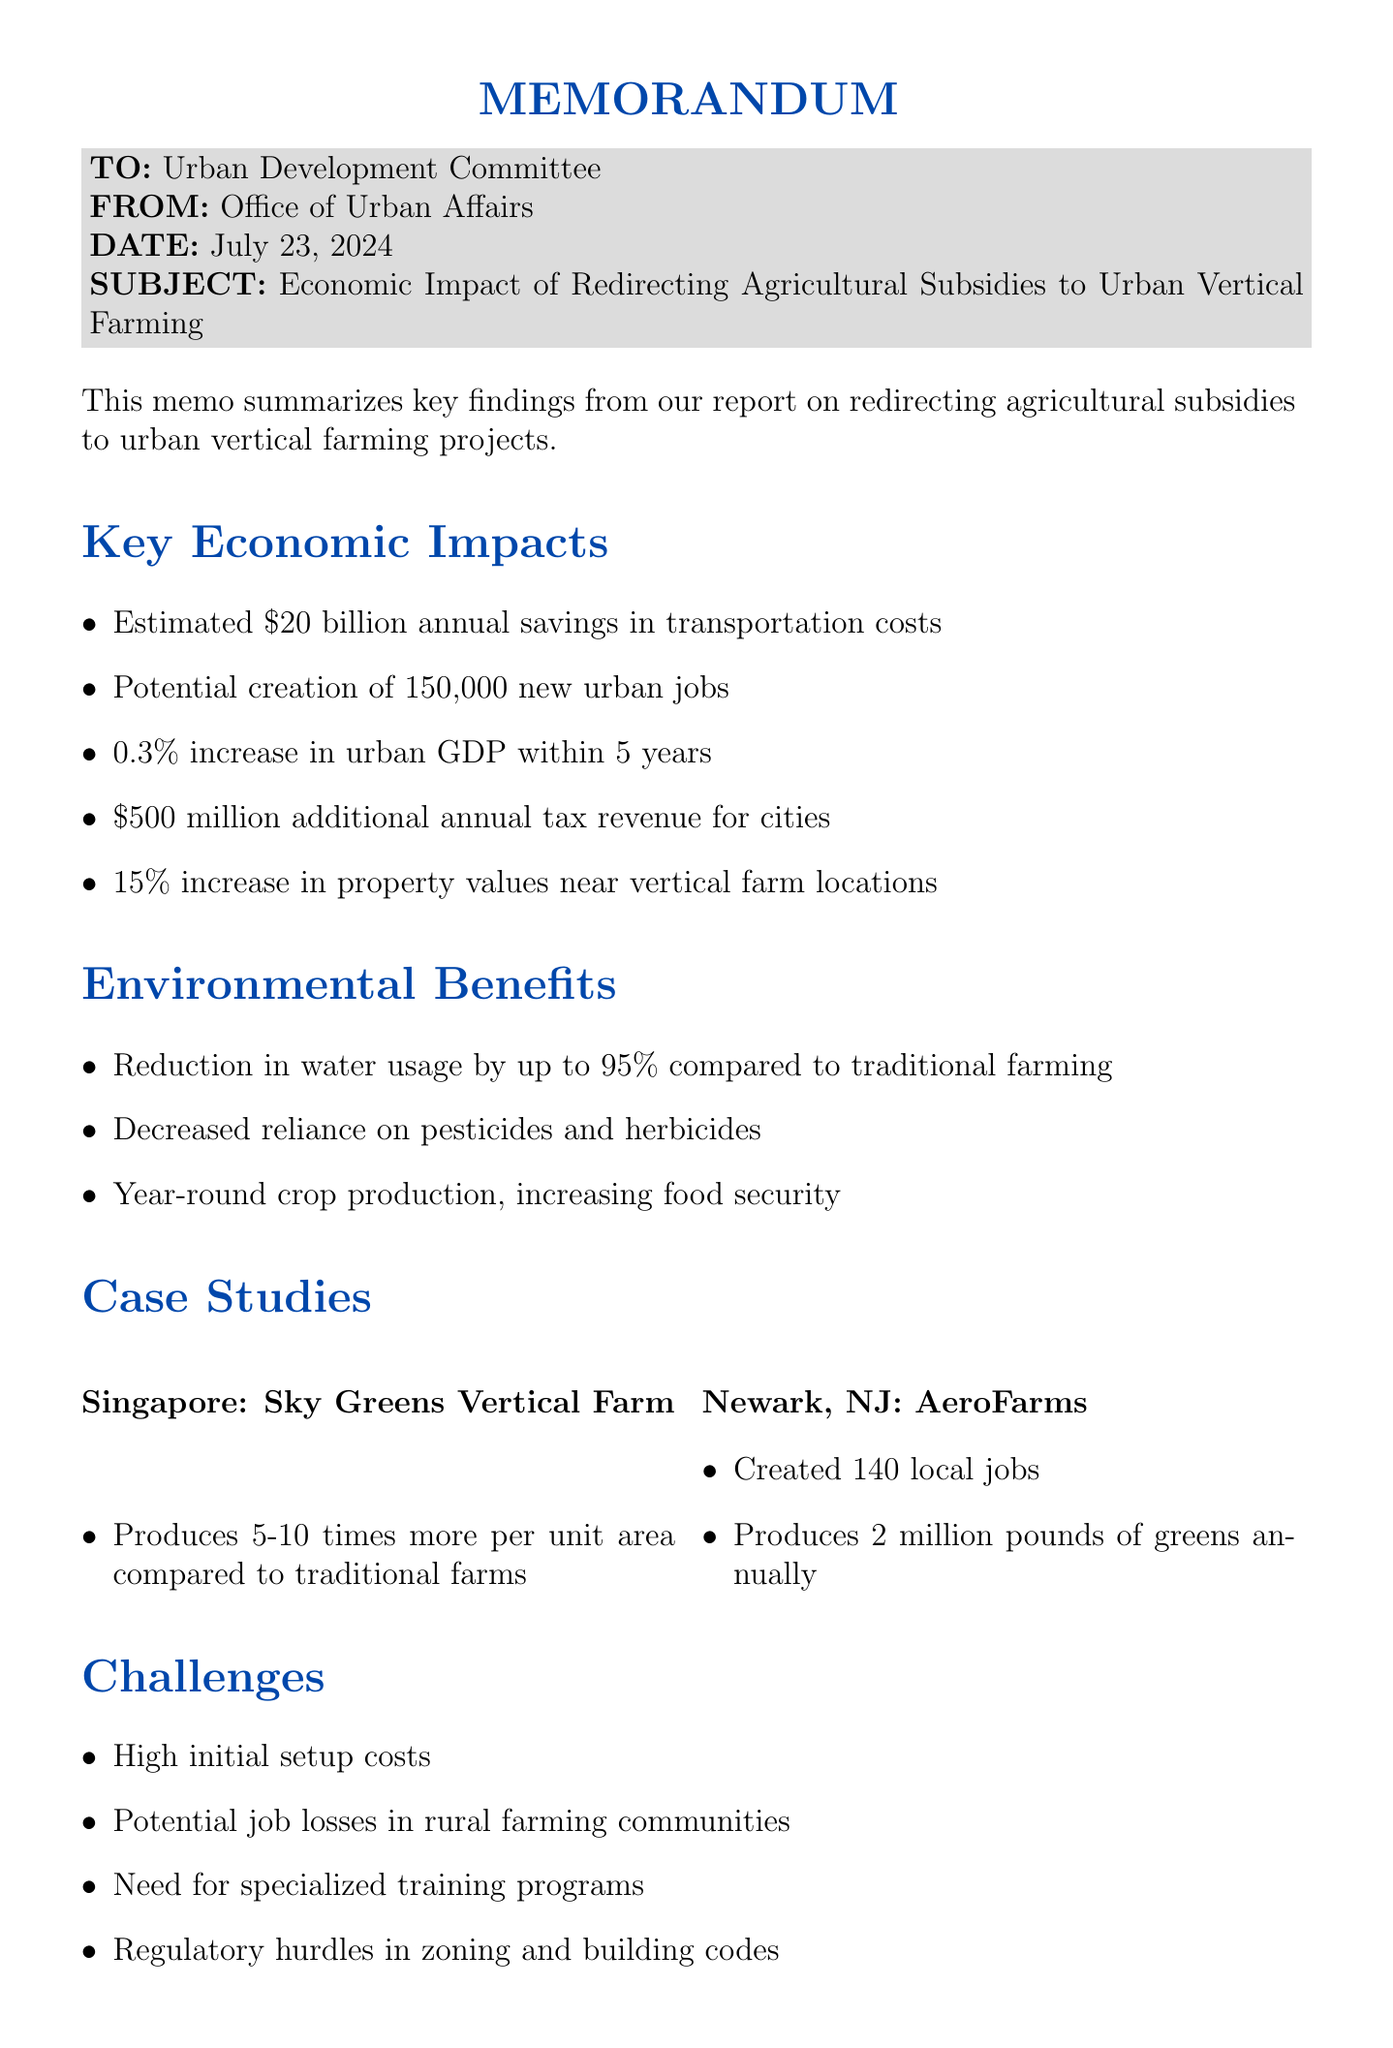what is the estimated annual savings in transportation costs? The estimated annual savings, as stated in the key points, is $20 billion.
Answer: $20 billion how many new urban jobs could potentially be created? The report mentions a potential creation of 150,000 new urban jobs.
Answer: 150,000 what percentage increase in urban GDP is projected within five years? The document states a projected increase of 0.3% in urban GDP within five years.
Answer: 0.3% what is the additional annual tax revenue for cities? The additional annual tax revenue for cities is noted as $500 million.
Answer: $500 million which city has the Sky Greens Vertical Farm project? According to the case studies, the Sky Greens Vertical Farm project is located in Singapore.
Answer: Singapore what is a significant challenge mentioned in the report? One significant challenge highlighted is the high initial setup costs for vertical farming infrastructure.
Answer: High initial setup costs what was the impact of AeroFarms on local job creation? The report states that AeroFarms created 140 local jobs.
Answer: 140 local jobs what is one of the recommendations for transitioning workers from rural areas? The document recommends creating job transition programs for rural agricultural workers.
Answer: Job transition programs who are some of the supporters of this initiative? Supporters include the United States Conference of Mayors and the American Planning Association.
Answer: United States Conference of Mayors, American Planning Association 